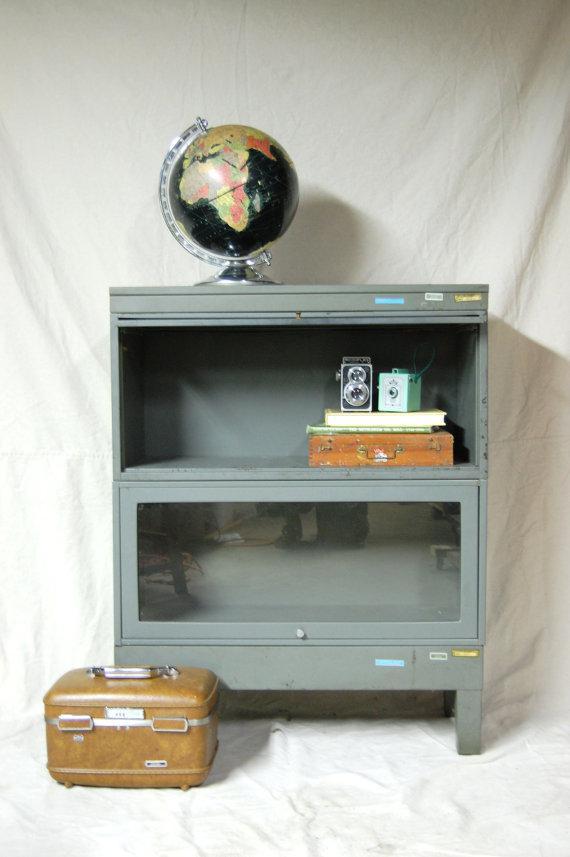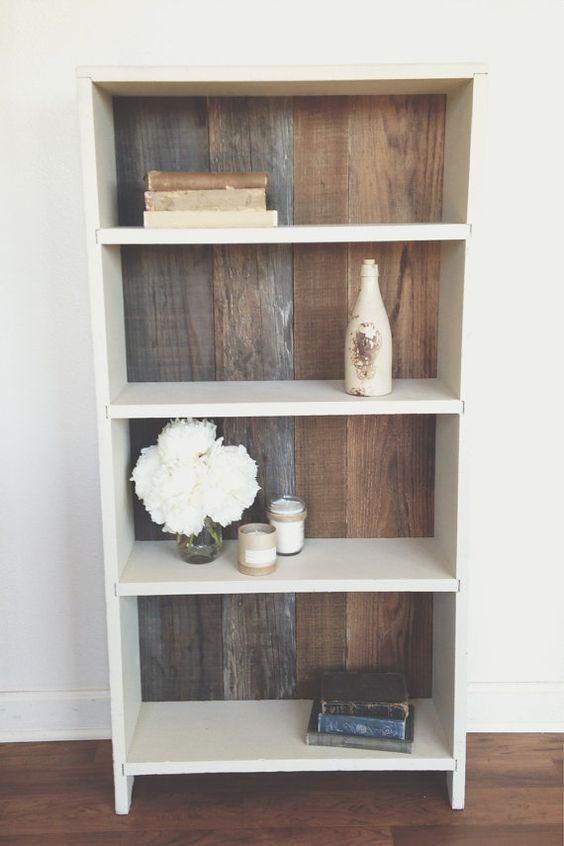The first image is the image on the left, the second image is the image on the right. Examine the images to the left and right. Is the description "Three white bookcases sit on a brown wood floor, and one of them has two vases on top." accurate? Answer yes or no. No. The first image is the image on the left, the second image is the image on the right. Given the left and right images, does the statement "At least one image shows a white cabinet containing some type of sky blue ceramic vessel." hold true? Answer yes or no. No. 